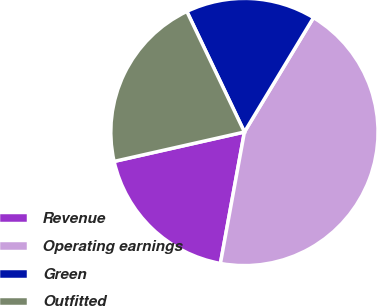Convert chart to OTSL. <chart><loc_0><loc_0><loc_500><loc_500><pie_chart><fcel>Revenue<fcel>Operating earnings<fcel>Green<fcel>Outfitted<nl><fcel>18.59%<fcel>44.23%<fcel>15.74%<fcel>21.44%<nl></chart> 